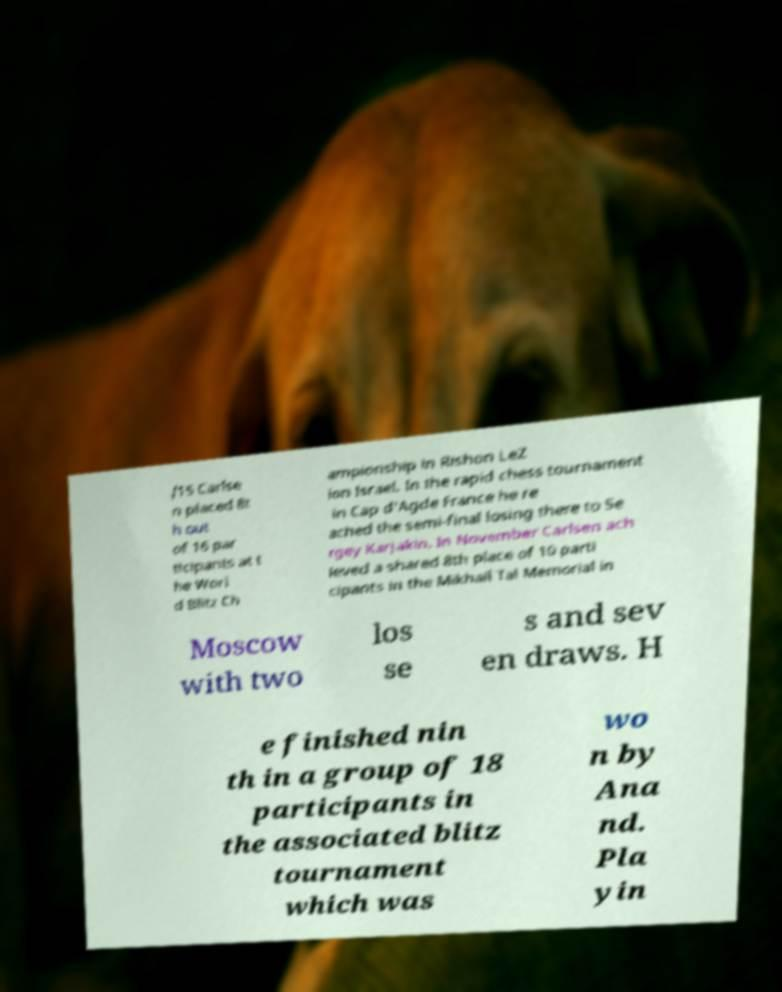Could you extract and type out the text from this image? /15 Carlse n placed 8t h out of 16 par ticipants at t he Worl d Blitz Ch ampionship in Rishon LeZ ion Israel. In the rapid chess tournament in Cap d'Agde France he re ached the semi-final losing there to Se rgey Karjakin. In November Carlsen ach ieved a shared 8th place of 10 parti cipants in the Mikhail Tal Memorial in Moscow with two los se s and sev en draws. H e finished nin th in a group of 18 participants in the associated blitz tournament which was wo n by Ana nd. Pla yin 